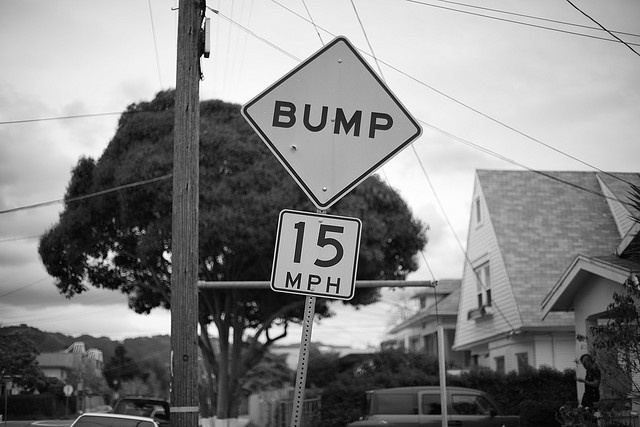Describe the objects in this image and their specific colors. I can see car in black, gray, and darkgray tones, car in black, gray, and darkgray tones, car in darkgray, gray, lightgray, and black tones, people in black, gray, and darkgray tones, and stop sign in gray, darkgray, and black tones in this image. 